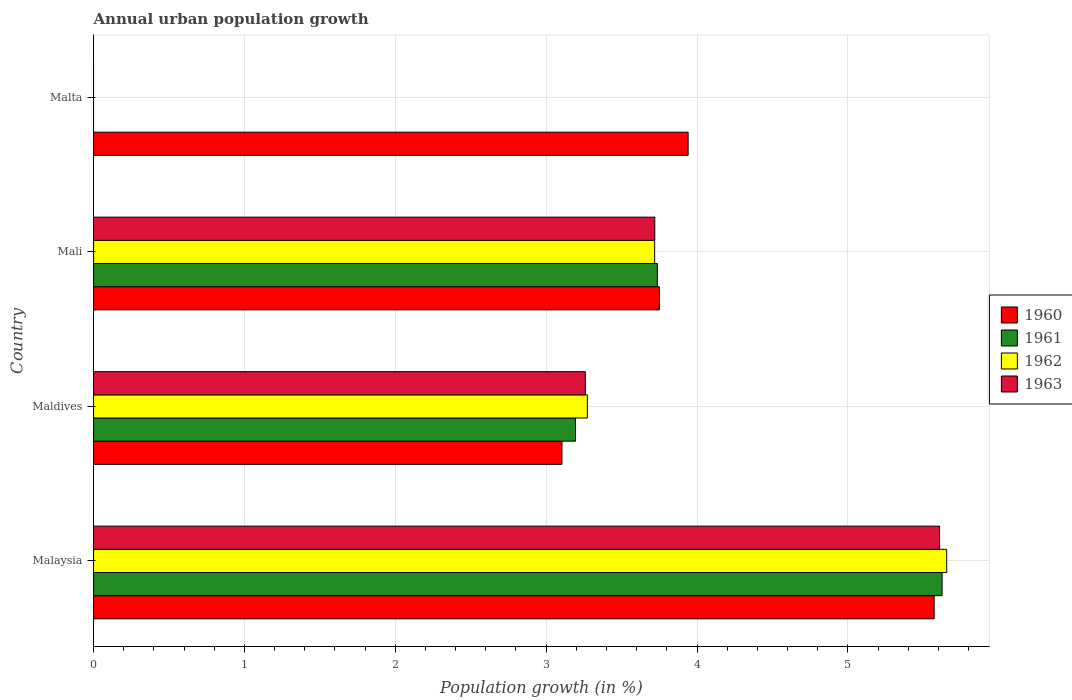Are the number of bars per tick equal to the number of legend labels?
Your answer should be very brief. No. How many bars are there on the 4th tick from the top?
Make the answer very short. 4. What is the label of the 4th group of bars from the top?
Your answer should be compact. Malaysia. In how many cases, is the number of bars for a given country not equal to the number of legend labels?
Make the answer very short. 1. What is the percentage of urban population growth in 1961 in Malaysia?
Offer a very short reply. 5.62. Across all countries, what is the maximum percentage of urban population growth in 1962?
Ensure brevity in your answer.  5.66. Across all countries, what is the minimum percentage of urban population growth in 1960?
Offer a very short reply. 3.1. In which country was the percentage of urban population growth in 1960 maximum?
Keep it short and to the point. Malaysia. What is the total percentage of urban population growth in 1963 in the graph?
Your answer should be very brief. 12.59. What is the difference between the percentage of urban population growth in 1960 in Maldives and that in Mali?
Your answer should be compact. -0.65. What is the difference between the percentage of urban population growth in 1960 in Malaysia and the percentage of urban population growth in 1963 in Mali?
Provide a succinct answer. 1.85. What is the average percentage of urban population growth in 1961 per country?
Ensure brevity in your answer.  3.14. What is the difference between the percentage of urban population growth in 1962 and percentage of urban population growth in 1960 in Mali?
Keep it short and to the point. -0.03. In how many countries, is the percentage of urban population growth in 1960 greater than 0.6000000000000001 %?
Keep it short and to the point. 4. What is the ratio of the percentage of urban population growth in 1961 in Malaysia to that in Mali?
Your answer should be very brief. 1.51. What is the difference between the highest and the second highest percentage of urban population growth in 1961?
Offer a terse response. 1.89. What is the difference between the highest and the lowest percentage of urban population growth in 1962?
Your answer should be very brief. 5.66. How many bars are there?
Your response must be concise. 13. How many countries are there in the graph?
Your answer should be very brief. 4. What is the difference between two consecutive major ticks on the X-axis?
Offer a very short reply. 1. Does the graph contain any zero values?
Your response must be concise. Yes. Where does the legend appear in the graph?
Give a very brief answer. Center right. How many legend labels are there?
Keep it short and to the point. 4. How are the legend labels stacked?
Keep it short and to the point. Vertical. What is the title of the graph?
Make the answer very short. Annual urban population growth. Does "1973" appear as one of the legend labels in the graph?
Offer a terse response. No. What is the label or title of the X-axis?
Your answer should be compact. Population growth (in %). What is the Population growth (in %) of 1960 in Malaysia?
Your response must be concise. 5.57. What is the Population growth (in %) of 1961 in Malaysia?
Keep it short and to the point. 5.62. What is the Population growth (in %) in 1962 in Malaysia?
Make the answer very short. 5.66. What is the Population growth (in %) of 1963 in Malaysia?
Make the answer very short. 5.61. What is the Population growth (in %) of 1960 in Maldives?
Your response must be concise. 3.1. What is the Population growth (in %) in 1961 in Maldives?
Ensure brevity in your answer.  3.19. What is the Population growth (in %) in 1962 in Maldives?
Ensure brevity in your answer.  3.27. What is the Population growth (in %) of 1963 in Maldives?
Provide a short and direct response. 3.26. What is the Population growth (in %) in 1960 in Mali?
Your answer should be compact. 3.75. What is the Population growth (in %) in 1961 in Mali?
Your answer should be compact. 3.74. What is the Population growth (in %) of 1962 in Mali?
Your answer should be compact. 3.72. What is the Population growth (in %) of 1963 in Mali?
Your answer should be very brief. 3.72. What is the Population growth (in %) in 1960 in Malta?
Your answer should be compact. 3.94. What is the Population growth (in %) of 1962 in Malta?
Your answer should be very brief. 0. What is the Population growth (in %) in 1963 in Malta?
Provide a short and direct response. 0. Across all countries, what is the maximum Population growth (in %) in 1960?
Keep it short and to the point. 5.57. Across all countries, what is the maximum Population growth (in %) in 1961?
Provide a succinct answer. 5.62. Across all countries, what is the maximum Population growth (in %) in 1962?
Offer a very short reply. 5.66. Across all countries, what is the maximum Population growth (in %) in 1963?
Your answer should be very brief. 5.61. Across all countries, what is the minimum Population growth (in %) of 1960?
Make the answer very short. 3.1. Across all countries, what is the minimum Population growth (in %) in 1963?
Ensure brevity in your answer.  0. What is the total Population growth (in %) in 1960 in the graph?
Your answer should be very brief. 16.37. What is the total Population growth (in %) of 1961 in the graph?
Your answer should be very brief. 12.56. What is the total Population growth (in %) of 1962 in the graph?
Provide a succinct answer. 12.65. What is the total Population growth (in %) of 1963 in the graph?
Your response must be concise. 12.59. What is the difference between the Population growth (in %) in 1960 in Malaysia and that in Maldives?
Make the answer very short. 2.47. What is the difference between the Population growth (in %) in 1961 in Malaysia and that in Maldives?
Provide a succinct answer. 2.43. What is the difference between the Population growth (in %) in 1962 in Malaysia and that in Maldives?
Your answer should be very brief. 2.38. What is the difference between the Population growth (in %) of 1963 in Malaysia and that in Maldives?
Your answer should be very brief. 2.35. What is the difference between the Population growth (in %) in 1960 in Malaysia and that in Mali?
Your response must be concise. 1.82. What is the difference between the Population growth (in %) in 1961 in Malaysia and that in Mali?
Make the answer very short. 1.89. What is the difference between the Population growth (in %) in 1962 in Malaysia and that in Mali?
Your answer should be very brief. 1.94. What is the difference between the Population growth (in %) in 1963 in Malaysia and that in Mali?
Provide a succinct answer. 1.89. What is the difference between the Population growth (in %) in 1960 in Malaysia and that in Malta?
Your answer should be compact. 1.63. What is the difference between the Population growth (in %) of 1960 in Maldives and that in Mali?
Provide a succinct answer. -0.65. What is the difference between the Population growth (in %) of 1961 in Maldives and that in Mali?
Keep it short and to the point. -0.54. What is the difference between the Population growth (in %) in 1962 in Maldives and that in Mali?
Your answer should be compact. -0.45. What is the difference between the Population growth (in %) in 1963 in Maldives and that in Mali?
Make the answer very short. -0.46. What is the difference between the Population growth (in %) of 1960 in Maldives and that in Malta?
Make the answer very short. -0.84. What is the difference between the Population growth (in %) of 1960 in Mali and that in Malta?
Keep it short and to the point. -0.19. What is the difference between the Population growth (in %) in 1960 in Malaysia and the Population growth (in %) in 1961 in Maldives?
Your answer should be compact. 2.38. What is the difference between the Population growth (in %) of 1960 in Malaysia and the Population growth (in %) of 1962 in Maldives?
Your answer should be very brief. 2.3. What is the difference between the Population growth (in %) in 1960 in Malaysia and the Population growth (in %) in 1963 in Maldives?
Your answer should be compact. 2.31. What is the difference between the Population growth (in %) in 1961 in Malaysia and the Population growth (in %) in 1962 in Maldives?
Ensure brevity in your answer.  2.35. What is the difference between the Population growth (in %) of 1961 in Malaysia and the Population growth (in %) of 1963 in Maldives?
Provide a short and direct response. 2.36. What is the difference between the Population growth (in %) of 1962 in Malaysia and the Population growth (in %) of 1963 in Maldives?
Your answer should be compact. 2.4. What is the difference between the Population growth (in %) in 1960 in Malaysia and the Population growth (in %) in 1961 in Mali?
Offer a very short reply. 1.84. What is the difference between the Population growth (in %) of 1960 in Malaysia and the Population growth (in %) of 1962 in Mali?
Keep it short and to the point. 1.85. What is the difference between the Population growth (in %) of 1960 in Malaysia and the Population growth (in %) of 1963 in Mali?
Provide a short and direct response. 1.85. What is the difference between the Population growth (in %) of 1961 in Malaysia and the Population growth (in %) of 1962 in Mali?
Give a very brief answer. 1.91. What is the difference between the Population growth (in %) of 1961 in Malaysia and the Population growth (in %) of 1963 in Mali?
Make the answer very short. 1.9. What is the difference between the Population growth (in %) of 1962 in Malaysia and the Population growth (in %) of 1963 in Mali?
Provide a short and direct response. 1.94. What is the difference between the Population growth (in %) in 1960 in Maldives and the Population growth (in %) in 1961 in Mali?
Offer a terse response. -0.63. What is the difference between the Population growth (in %) of 1960 in Maldives and the Population growth (in %) of 1962 in Mali?
Offer a very short reply. -0.61. What is the difference between the Population growth (in %) in 1960 in Maldives and the Population growth (in %) in 1963 in Mali?
Provide a succinct answer. -0.62. What is the difference between the Population growth (in %) in 1961 in Maldives and the Population growth (in %) in 1962 in Mali?
Ensure brevity in your answer.  -0.52. What is the difference between the Population growth (in %) of 1961 in Maldives and the Population growth (in %) of 1963 in Mali?
Provide a succinct answer. -0.53. What is the difference between the Population growth (in %) of 1962 in Maldives and the Population growth (in %) of 1963 in Mali?
Keep it short and to the point. -0.45. What is the average Population growth (in %) in 1960 per country?
Make the answer very short. 4.09. What is the average Population growth (in %) of 1961 per country?
Provide a short and direct response. 3.14. What is the average Population growth (in %) of 1962 per country?
Make the answer very short. 3.16. What is the average Population growth (in %) in 1963 per country?
Give a very brief answer. 3.15. What is the difference between the Population growth (in %) of 1960 and Population growth (in %) of 1961 in Malaysia?
Provide a short and direct response. -0.05. What is the difference between the Population growth (in %) in 1960 and Population growth (in %) in 1962 in Malaysia?
Provide a succinct answer. -0.08. What is the difference between the Population growth (in %) of 1960 and Population growth (in %) of 1963 in Malaysia?
Offer a very short reply. -0.04. What is the difference between the Population growth (in %) of 1961 and Population growth (in %) of 1962 in Malaysia?
Offer a very short reply. -0.03. What is the difference between the Population growth (in %) in 1961 and Population growth (in %) in 1963 in Malaysia?
Give a very brief answer. 0.02. What is the difference between the Population growth (in %) of 1962 and Population growth (in %) of 1963 in Malaysia?
Ensure brevity in your answer.  0.05. What is the difference between the Population growth (in %) of 1960 and Population growth (in %) of 1961 in Maldives?
Provide a succinct answer. -0.09. What is the difference between the Population growth (in %) of 1960 and Population growth (in %) of 1962 in Maldives?
Give a very brief answer. -0.17. What is the difference between the Population growth (in %) of 1960 and Population growth (in %) of 1963 in Maldives?
Offer a very short reply. -0.16. What is the difference between the Population growth (in %) in 1961 and Population growth (in %) in 1962 in Maldives?
Provide a short and direct response. -0.08. What is the difference between the Population growth (in %) of 1961 and Population growth (in %) of 1963 in Maldives?
Your response must be concise. -0.07. What is the difference between the Population growth (in %) of 1962 and Population growth (in %) of 1963 in Maldives?
Your answer should be compact. 0.01. What is the difference between the Population growth (in %) of 1960 and Population growth (in %) of 1961 in Mali?
Keep it short and to the point. 0.01. What is the difference between the Population growth (in %) of 1960 and Population growth (in %) of 1962 in Mali?
Your answer should be compact. 0.03. What is the difference between the Population growth (in %) of 1960 and Population growth (in %) of 1963 in Mali?
Give a very brief answer. 0.03. What is the difference between the Population growth (in %) in 1961 and Population growth (in %) in 1962 in Mali?
Make the answer very short. 0.02. What is the difference between the Population growth (in %) of 1961 and Population growth (in %) of 1963 in Mali?
Provide a short and direct response. 0.02. What is the difference between the Population growth (in %) in 1962 and Population growth (in %) in 1963 in Mali?
Your answer should be very brief. -0. What is the ratio of the Population growth (in %) in 1960 in Malaysia to that in Maldives?
Provide a short and direct response. 1.79. What is the ratio of the Population growth (in %) of 1961 in Malaysia to that in Maldives?
Your answer should be compact. 1.76. What is the ratio of the Population growth (in %) in 1962 in Malaysia to that in Maldives?
Your answer should be very brief. 1.73. What is the ratio of the Population growth (in %) of 1963 in Malaysia to that in Maldives?
Keep it short and to the point. 1.72. What is the ratio of the Population growth (in %) of 1960 in Malaysia to that in Mali?
Offer a terse response. 1.49. What is the ratio of the Population growth (in %) of 1961 in Malaysia to that in Mali?
Make the answer very short. 1.51. What is the ratio of the Population growth (in %) in 1962 in Malaysia to that in Mali?
Give a very brief answer. 1.52. What is the ratio of the Population growth (in %) in 1963 in Malaysia to that in Mali?
Offer a terse response. 1.51. What is the ratio of the Population growth (in %) of 1960 in Malaysia to that in Malta?
Offer a terse response. 1.41. What is the ratio of the Population growth (in %) of 1960 in Maldives to that in Mali?
Provide a short and direct response. 0.83. What is the ratio of the Population growth (in %) in 1961 in Maldives to that in Mali?
Give a very brief answer. 0.85. What is the ratio of the Population growth (in %) in 1962 in Maldives to that in Mali?
Give a very brief answer. 0.88. What is the ratio of the Population growth (in %) of 1963 in Maldives to that in Mali?
Offer a terse response. 0.88. What is the ratio of the Population growth (in %) of 1960 in Maldives to that in Malta?
Your answer should be compact. 0.79. What is the ratio of the Population growth (in %) in 1960 in Mali to that in Malta?
Make the answer very short. 0.95. What is the difference between the highest and the second highest Population growth (in %) in 1960?
Keep it short and to the point. 1.63. What is the difference between the highest and the second highest Population growth (in %) of 1961?
Ensure brevity in your answer.  1.89. What is the difference between the highest and the second highest Population growth (in %) in 1962?
Ensure brevity in your answer.  1.94. What is the difference between the highest and the second highest Population growth (in %) of 1963?
Keep it short and to the point. 1.89. What is the difference between the highest and the lowest Population growth (in %) of 1960?
Offer a very short reply. 2.47. What is the difference between the highest and the lowest Population growth (in %) of 1961?
Offer a very short reply. 5.62. What is the difference between the highest and the lowest Population growth (in %) of 1962?
Provide a short and direct response. 5.66. What is the difference between the highest and the lowest Population growth (in %) in 1963?
Provide a succinct answer. 5.61. 